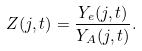Convert formula to latex. <formula><loc_0><loc_0><loc_500><loc_500>Z ( j , t ) = \frac { Y _ { e } ( j , t ) } { Y _ { A } ( j , t ) } .</formula> 